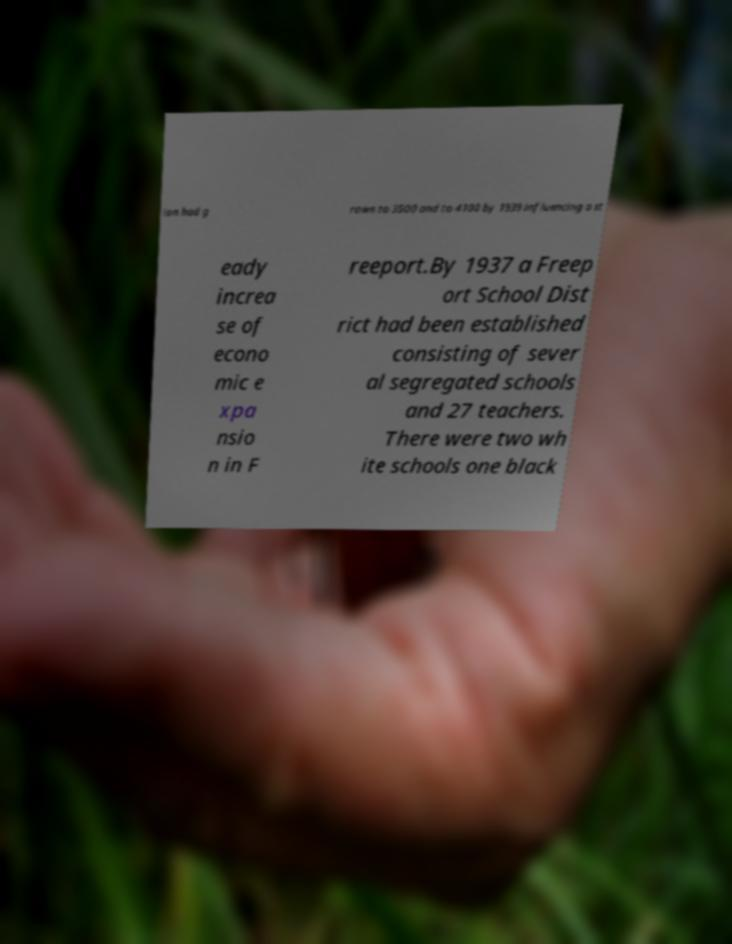Can you read and provide the text displayed in the image?This photo seems to have some interesting text. Can you extract and type it out for me? ion had g rown to 3500 and to 4100 by 1939 influencing a st eady increa se of econo mic e xpa nsio n in F reeport.By 1937 a Freep ort School Dist rict had been established consisting of sever al segregated schools and 27 teachers. There were two wh ite schools one black 